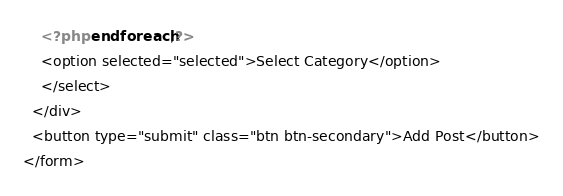Convert code to text. <code><loc_0><loc_0><loc_500><loc_500><_PHP_>    <?php endforeach;?>
    <option selected="selected">Select Category</option>
    </select>
  </div>
  <button type="submit" class="btn btn-secondary">Add Post</button>
</form>  
</code> 